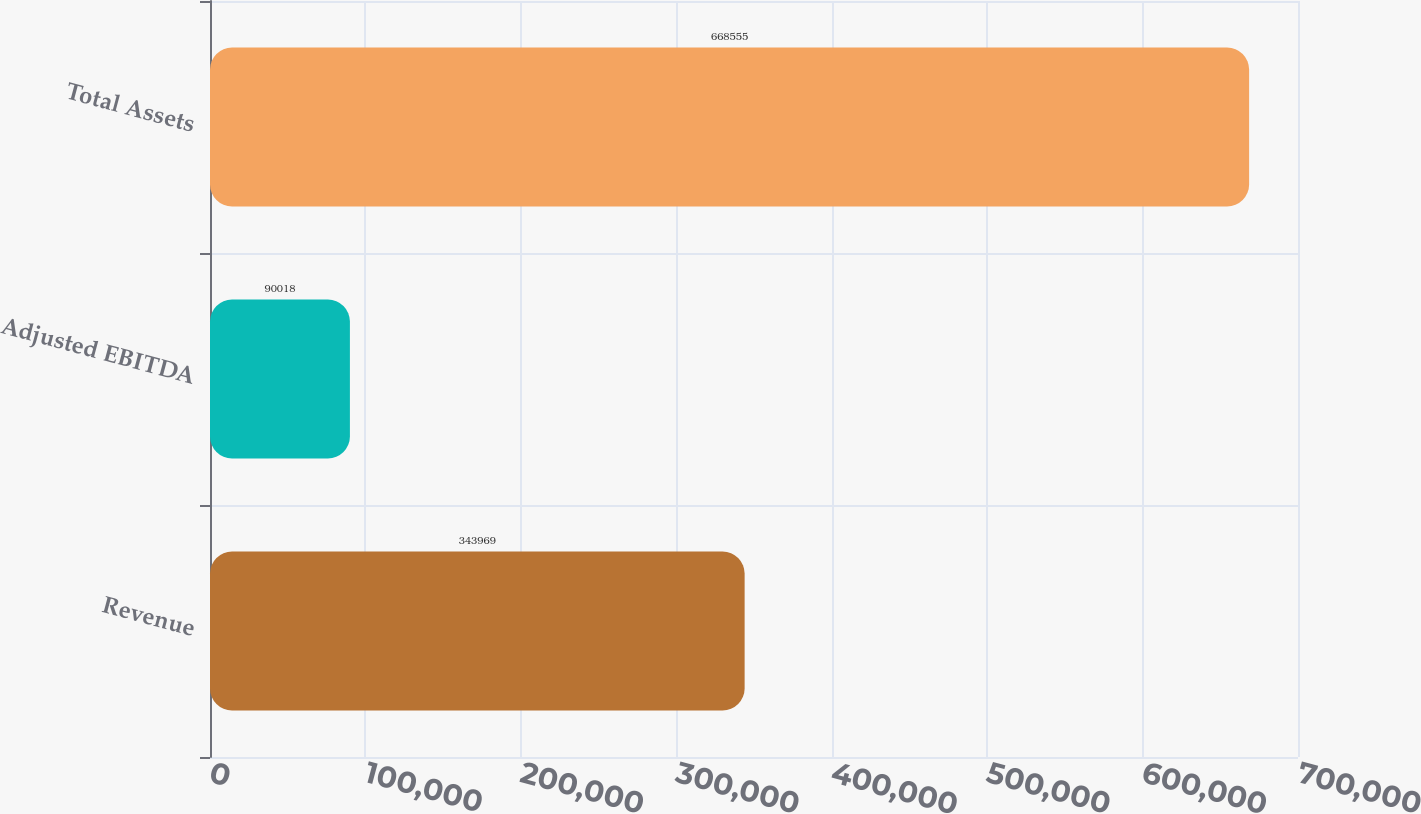Convert chart. <chart><loc_0><loc_0><loc_500><loc_500><bar_chart><fcel>Revenue<fcel>Adjusted EBITDA<fcel>Total Assets<nl><fcel>343969<fcel>90018<fcel>668555<nl></chart> 